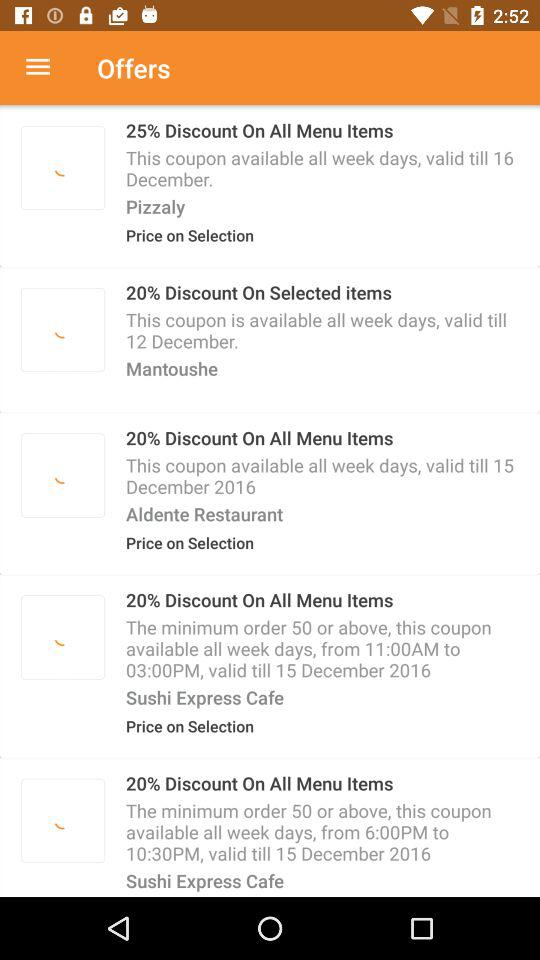How much is the discounted offer on Pizzaly? The discounted offer on Pizzaly is a 25% discount on all menu items. 